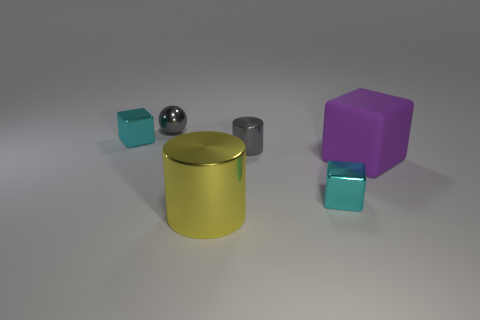Subtract all tiny cubes. How many cubes are left? 1 Subtract 1 spheres. How many spheres are left? 0 Subtract all cyan cubes. How many cubes are left? 1 Subtract all spheres. How many objects are left? 5 Add 1 green metallic blocks. How many objects exist? 7 Add 6 gray shiny objects. How many gray shiny objects are left? 8 Add 1 large metallic cylinders. How many large metallic cylinders exist? 2 Subtract 0 cyan spheres. How many objects are left? 6 Subtract all gray blocks. Subtract all blue cylinders. How many blocks are left? 3 Subtract all blue balls. How many green cubes are left? 0 